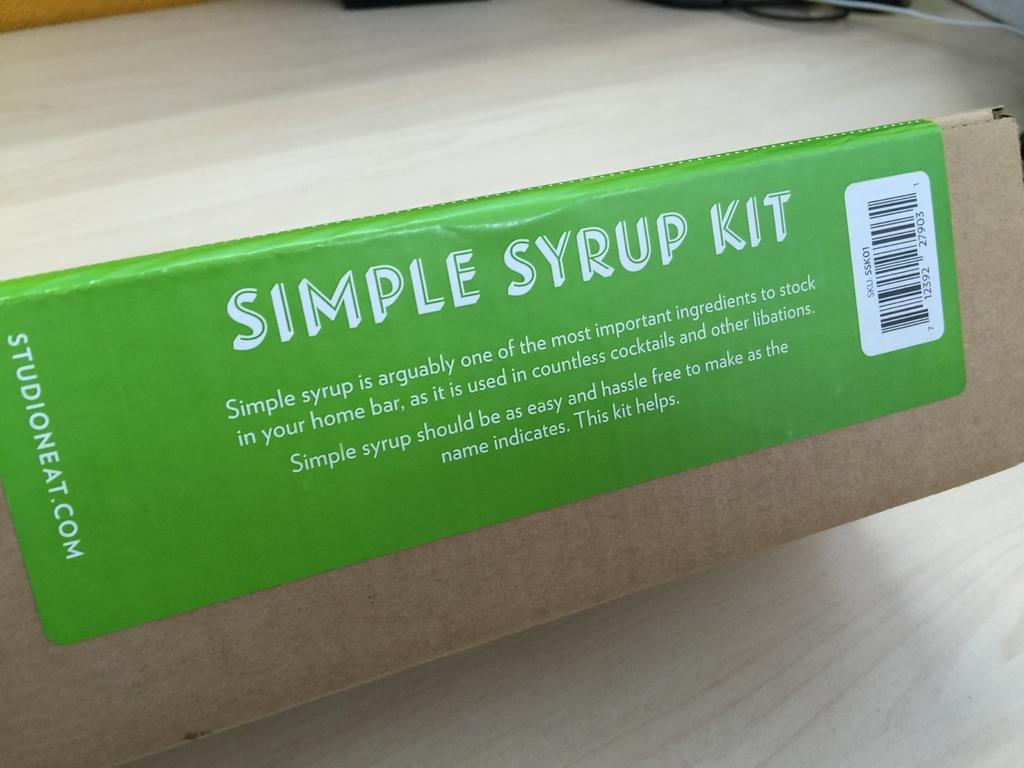<image>
Render a clear and concise summary of the photo. A green label reads"Simple Syrup Kit" in white letters. 